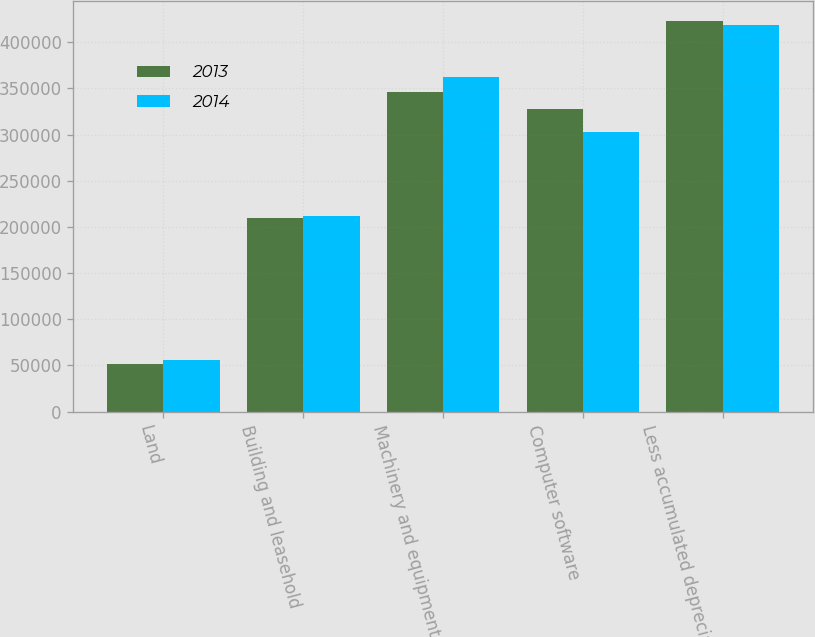Convert chart to OTSL. <chart><loc_0><loc_0><loc_500><loc_500><stacked_bar_chart><ecel><fcel>Land<fcel>Building and leasehold<fcel>Machinery and equipment<fcel>Computer software<fcel>Less accumulated depreciation<nl><fcel>2013<fcel>51123<fcel>210008<fcel>345888<fcel>327753<fcel>423310<nl><fcel>2014<fcel>56214<fcel>212277<fcel>361978<fcel>302681<fcel>418712<nl></chart> 